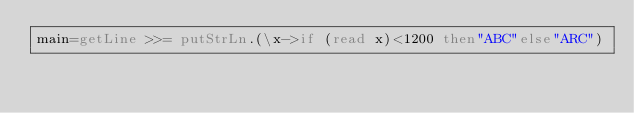<code> <loc_0><loc_0><loc_500><loc_500><_Haskell_>main=getLine >>= putStrLn.(\x->if (read x)<1200 then"ABC"else"ARC")</code> 